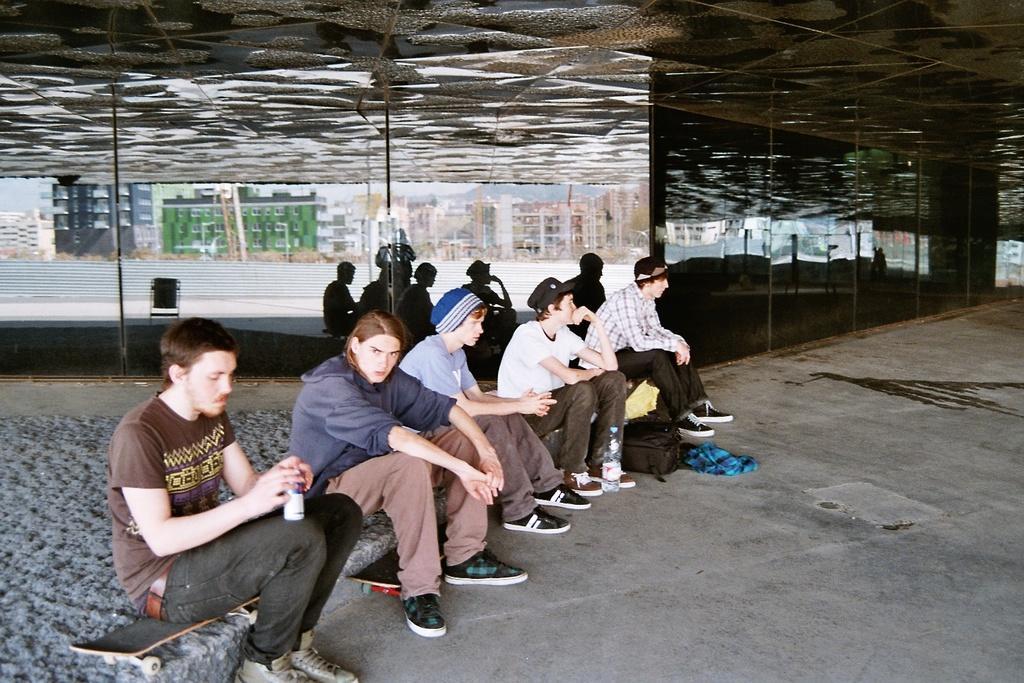In one or two sentences, can you explain what this image depicts? In the image I can see people are sitting among them the person on the left side is holding some object in hands. I can also see a bottle, bag, clothes, skateboards and some other objects on the ground. In the background I can see framed glass wall, buildings and some other objects. 